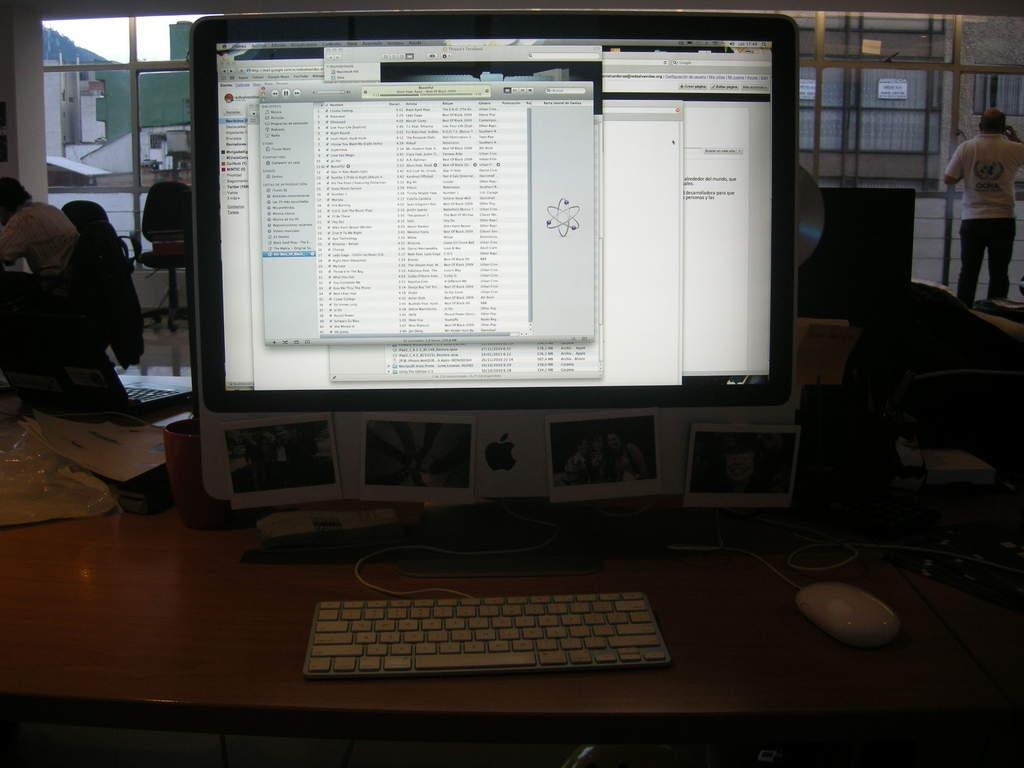<image>
Give a short and clear explanation of the subsequent image. An Apple computer sits on a desk displaying several different programs. 